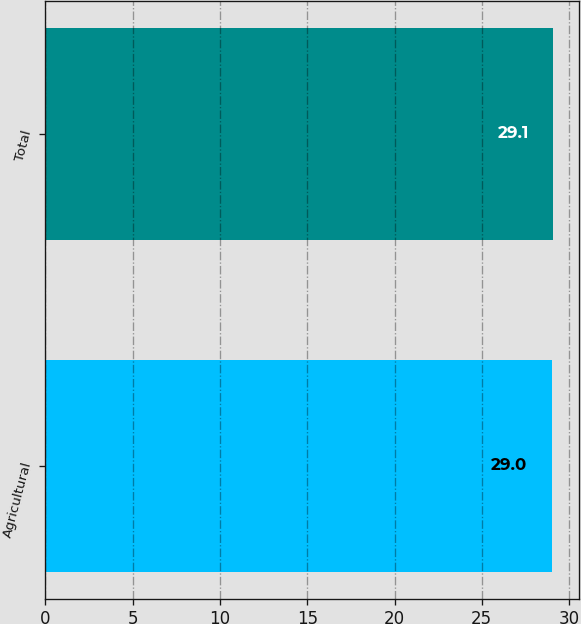Convert chart to OTSL. <chart><loc_0><loc_0><loc_500><loc_500><bar_chart><fcel>Agricultural<fcel>Total<nl><fcel>29<fcel>29.1<nl></chart> 